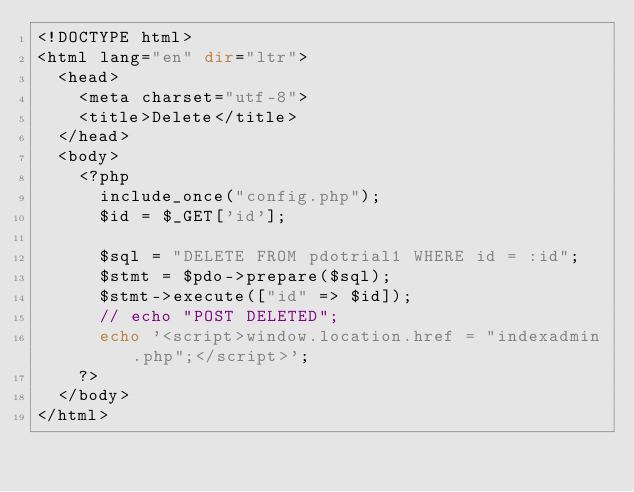Convert code to text. <code><loc_0><loc_0><loc_500><loc_500><_PHP_><!DOCTYPE html>
<html lang="en" dir="ltr">
  <head>
    <meta charset="utf-8">
    <title>Delete</title>
  </head>
  <body>
    <?php
      include_once("config.php");
      $id = $_GET['id'];

      $sql = "DELETE FROM pdotrial1 WHERE id = :id";
      $stmt = $pdo->prepare($sql);
      $stmt->execute(["id" => $id]);
      // echo "POST DELETED";
      echo '<script>window.location.href = "indexadmin.php";</script>';
    ?>
  </body>
</html>
</code> 